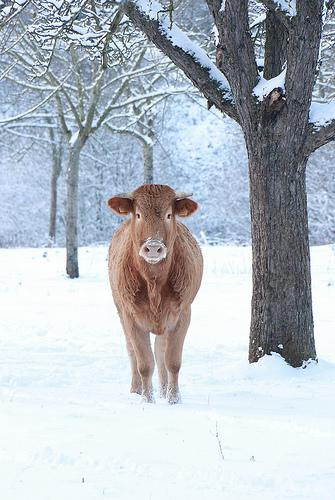Question: what is in the snow?
Choices:
A. Duck.
B. Dog.
C. Cow.
D. Rabbit.
Answer with the letter. Answer: C Question: where is the cow?
Choices:
A. Barn.
B. Farm.
C. Forest.
D. Field.
Answer with the letter. Answer: C Question: what color is the cow's nose?
Choices:
A. Pink.
B. Brown.
C. Black.
D. Tan.
Answer with the letter. Answer: D Question: who is with the cow?
Choices:
A. No one.
B. Cow.
C. Sheep.
D. Pig.
Answer with the letter. Answer: A Question: what is planted in the ground?
Choices:
A. Flower.
B. Weed.
C. Trees.
D. Bush.
Answer with the letter. Answer: C Question: what is covering the ground?
Choices:
A. Grass.
B. Dirt.
C. Snow.
D. Sand.
Answer with the letter. Answer: C 